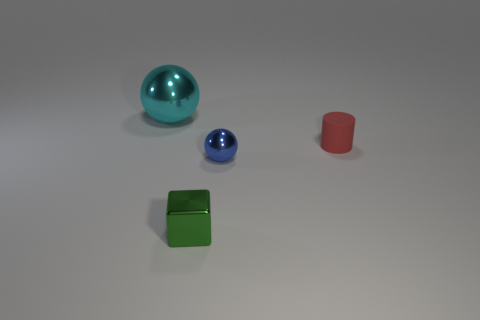How many other tiny things have the same shape as the green metal thing?
Your response must be concise. 0. What number of gray objects are blocks or tiny shiny objects?
Keep it short and to the point. 0. What is the size of the shiny ball that is on the left side of the tiny object in front of the tiny sphere?
Your answer should be very brief. Large. How many blue shiny spheres are the same size as the rubber object?
Offer a terse response. 1. Do the blue ball and the cyan metallic object have the same size?
Your response must be concise. No. How big is the thing that is behind the tiny metal sphere and left of the tiny red thing?
Provide a succinct answer. Large. Is the number of metal spheres that are to the right of the tiny green shiny object greater than the number of red rubber cylinders that are in front of the blue ball?
Your answer should be very brief. Yes. The big thing that is the same shape as the tiny blue object is what color?
Make the answer very short. Cyan. What number of tiny metal objects are there?
Offer a terse response. 2. Is the material of the sphere in front of the cyan object the same as the green cube?
Offer a very short reply. Yes. 